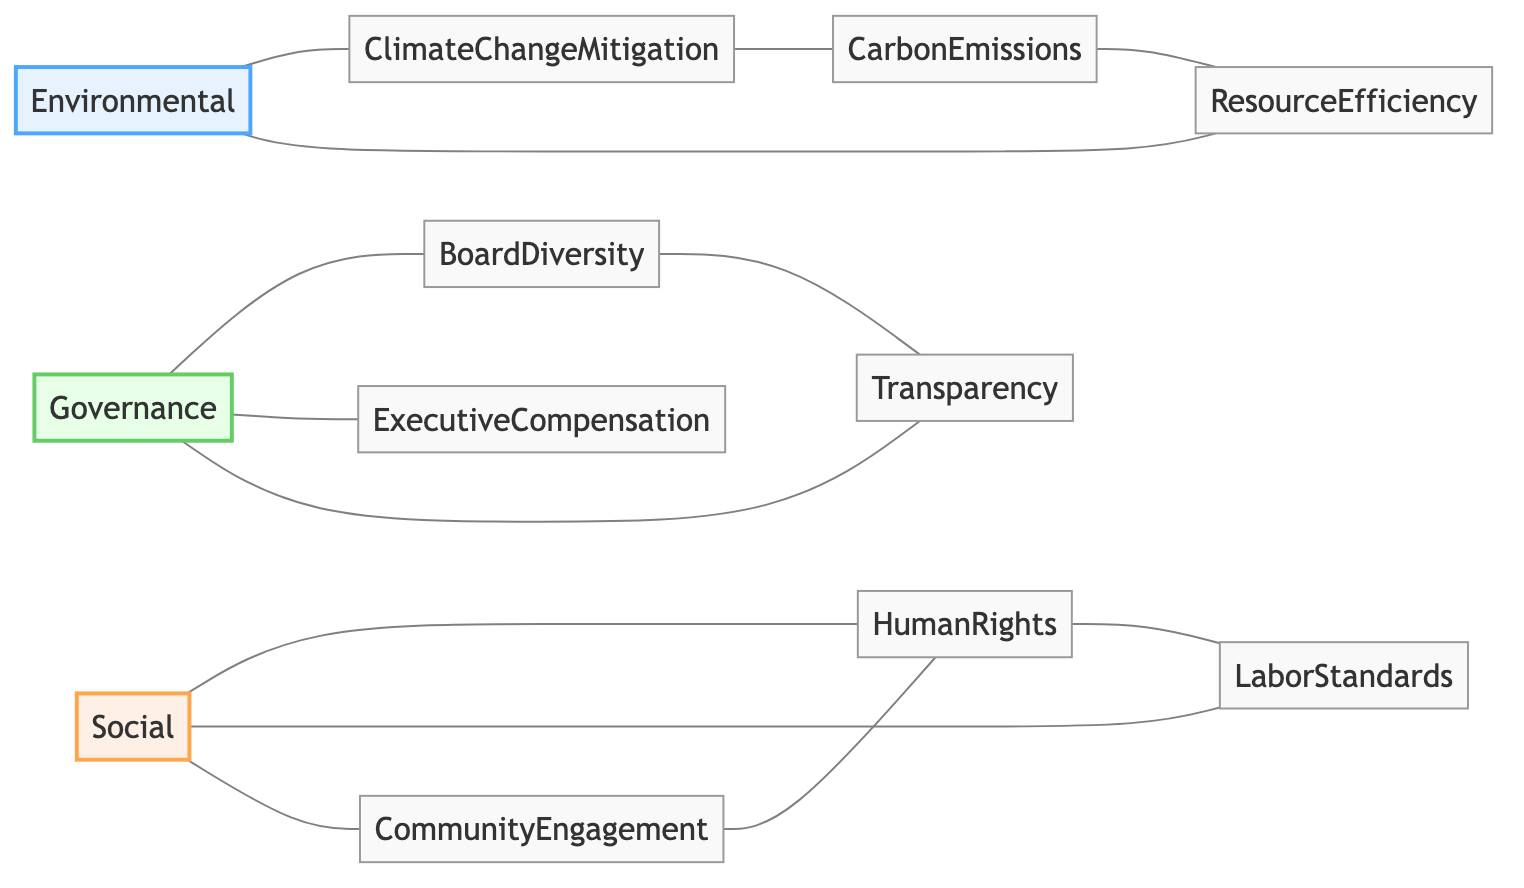What are the major categories represented in the diagram? The diagram primarily features three major categories: Environmental, Social, and Governance. Each category serves as a node that connects to various specific factors related to ethical investing.
Answer: Environmental, Social, Governance How many nodes are there in the diagram? By counting the individual nodes listed in the data, we find there are 12 distinct nodes in total that represent different factors in the context of ESG.
Answer: 12 Which node is connected to Resource Efficiency? By examining the edges connected to Resource Efficiency, we observe that it is directly linked to Environmental and Carbon Emissions.
Answer: Environmental, Carbon Emissions What relationship exists between Human Rights and Labor Standards? Human Rights and Labor Standards are connected, indicating a direct relationship where one influences or relates to the other within the social aspect of ESG.
Answer: Connected How many edges belong to the Governance category? To answer this, we must count the edges that originate from the Governance node, which includes connections to Board Diversity, Executive Compensation, and Transparency, resulting in a total of 3 edges.
Answer: 3 Which specific factor contributes to Climate Change Mitigation? The specific factor that contributes to Climate Change Mitigation is Carbon Emissions, which is directly connected, indicating its relevance to the climate efforts represented in the diagram.
Answer: Carbon Emissions What type of interaction exists between Community Engagement and Human Rights? Community Engagement is connected to Human Rights, suggesting a reciprocal or supportive relationship where engagement in the community can positively affect human rights initiatives.
Answer: Connected Which node features the most connections? By analyzing the connections made in the diagram, we find that the Social node has the most connections, linking it to Human Rights, Labor Standards, and Community Engagement.
Answer: Social How does Board Diversity relate to Transparency? Board Diversity has a direct connection to Transparency, indicating that the quality of board representation may have implications for the transparency of governance practices.
Answer: Connected 